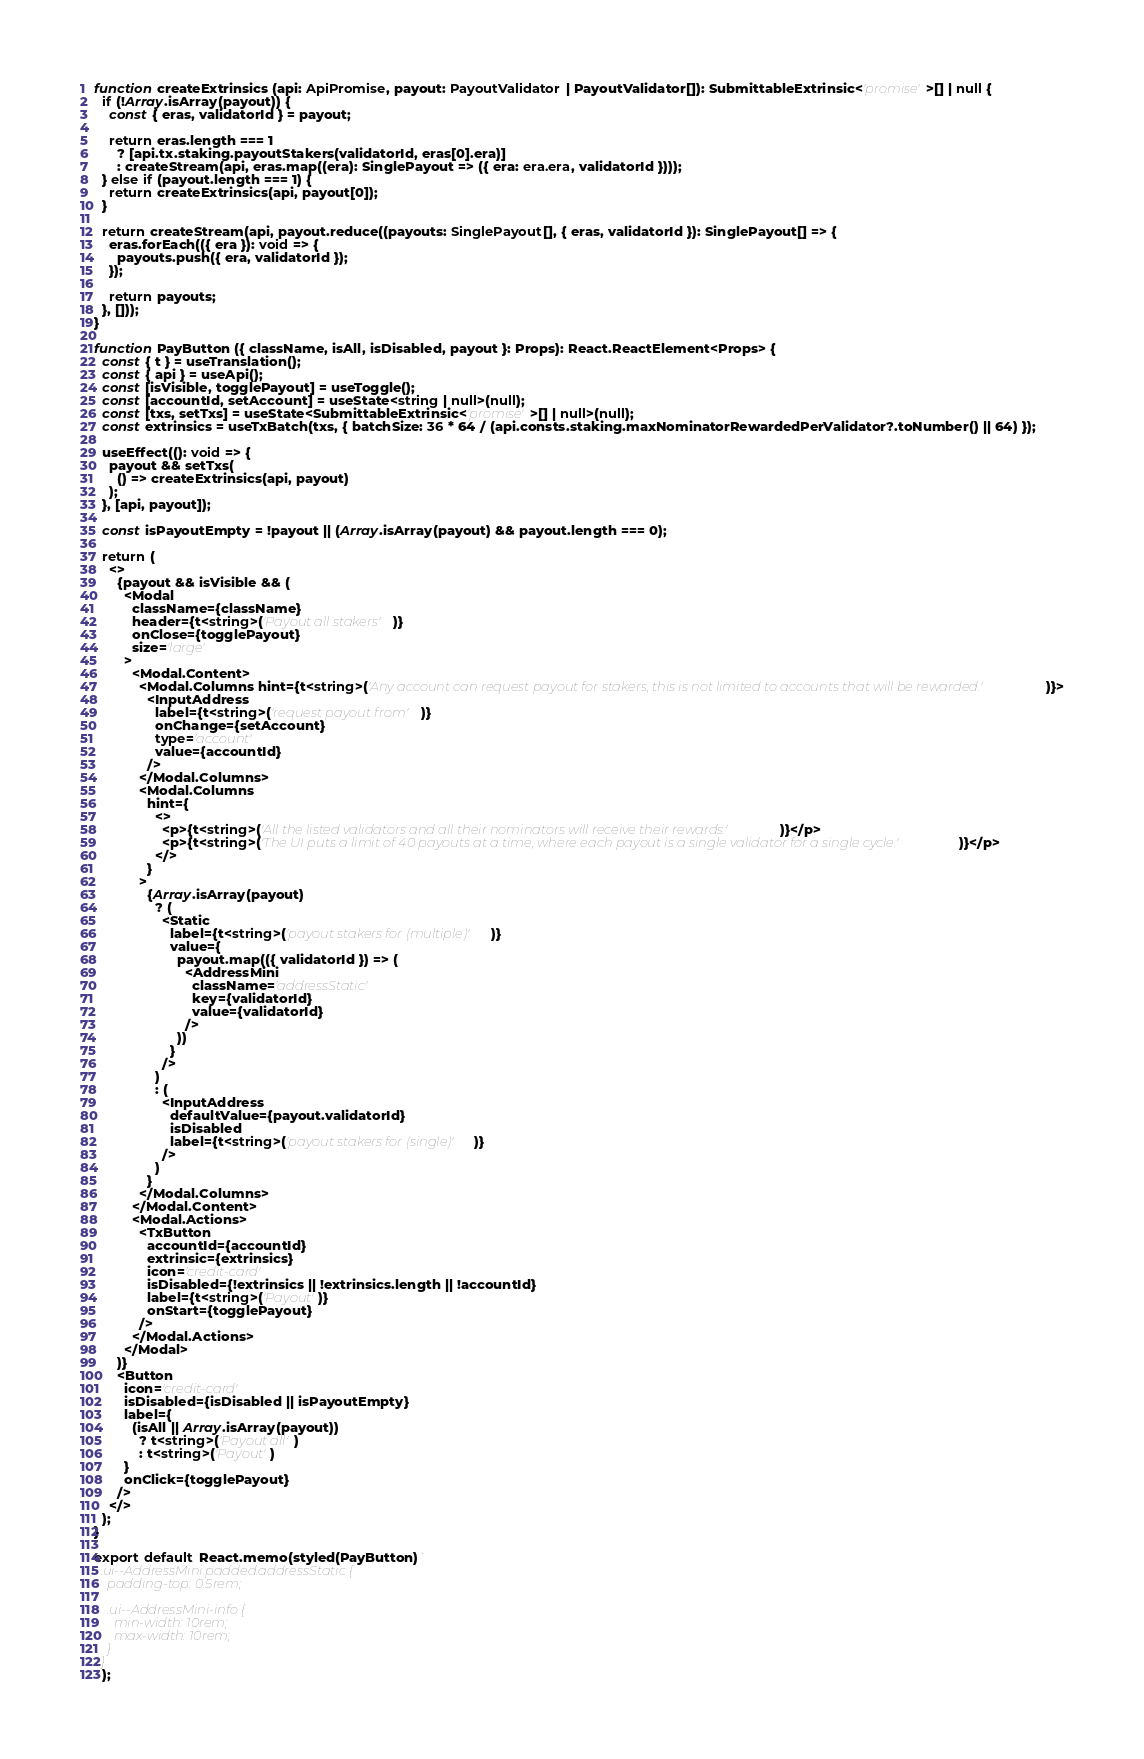Convert code to text. <code><loc_0><loc_0><loc_500><loc_500><_TypeScript_>function createExtrinsics (api: ApiPromise, payout: PayoutValidator | PayoutValidator[]): SubmittableExtrinsic<'promise'>[] | null {
  if (!Array.isArray(payout)) {
    const { eras, validatorId } = payout;

    return eras.length === 1
      ? [api.tx.staking.payoutStakers(validatorId, eras[0].era)]
      : createStream(api, eras.map((era): SinglePayout => ({ era: era.era, validatorId })));
  } else if (payout.length === 1) {
    return createExtrinsics(api, payout[0]);
  }

  return createStream(api, payout.reduce((payouts: SinglePayout[], { eras, validatorId }): SinglePayout[] => {
    eras.forEach(({ era }): void => {
      payouts.push({ era, validatorId });
    });

    return payouts;
  }, []));
}

function PayButton ({ className, isAll, isDisabled, payout }: Props): React.ReactElement<Props> {
  const { t } = useTranslation();
  const { api } = useApi();
  const [isVisible, togglePayout] = useToggle();
  const [accountId, setAccount] = useState<string | null>(null);
  const [txs, setTxs] = useState<SubmittableExtrinsic<'promise'>[] | null>(null);
  const extrinsics = useTxBatch(txs, { batchSize: 36 * 64 / (api.consts.staking.maxNominatorRewardedPerValidator?.toNumber() || 64) });

  useEffect((): void => {
    payout && setTxs(
      () => createExtrinsics(api, payout)
    );
  }, [api, payout]);

  const isPayoutEmpty = !payout || (Array.isArray(payout) && payout.length === 0);

  return (
    <>
      {payout && isVisible && (
        <Modal
          className={className}
          header={t<string>('Payout all stakers')}
          onClose={togglePayout}
          size='large'
        >
          <Modal.Content>
            <Modal.Columns hint={t<string>('Any account can request payout for stakers, this is not limited to accounts that will be rewarded.')}>
              <InputAddress
                label={t<string>('request payout from')}
                onChange={setAccount}
                type='account'
                value={accountId}
              />
            </Modal.Columns>
            <Modal.Columns
              hint={
                <>
                  <p>{t<string>('All the listed validators and all their nominators will receive their rewards.')}</p>
                  <p>{t<string>('The UI puts a limit of 40 payouts at a time, where each payout is a single validator for a single cycle.')}</p>
                </>
              }
            >
              {Array.isArray(payout)
                ? (
                  <Static
                    label={t<string>('payout stakers for (multiple)')}
                    value={
                      payout.map(({ validatorId }) => (
                        <AddressMini
                          className='addressStatic'
                          key={validatorId}
                          value={validatorId}
                        />
                      ))
                    }
                  />
                )
                : (
                  <InputAddress
                    defaultValue={payout.validatorId}
                    isDisabled
                    label={t<string>('payout stakers for (single)')}
                  />
                )
              }
            </Modal.Columns>
          </Modal.Content>
          <Modal.Actions>
            <TxButton
              accountId={accountId}
              extrinsic={extrinsics}
              icon='credit-card'
              isDisabled={!extrinsics || !extrinsics.length || !accountId}
              label={t<string>('Payout')}
              onStart={togglePayout}
            />
          </Modal.Actions>
        </Modal>
      )}
      <Button
        icon='credit-card'
        isDisabled={isDisabled || isPayoutEmpty}
        label={
          (isAll || Array.isArray(payout))
            ? t<string>('Payout all')
            : t<string>('Payout')
        }
        onClick={togglePayout}
      />
    </>
  );
}

export default React.memo(styled(PayButton)`
  .ui--AddressMini.padded.addressStatic {
    padding-top: 0.5rem;

    .ui--AddressMini-info {
      min-width: 10rem;
      max-width: 10rem;
    }
  }
`);
</code> 